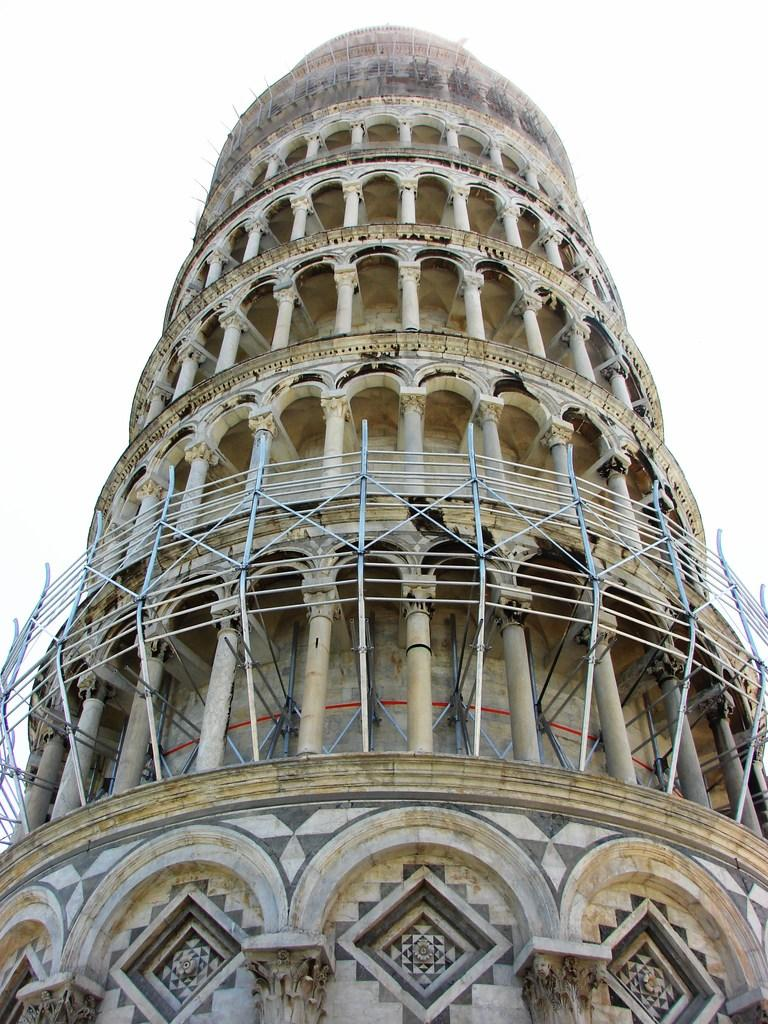What is the main structure in the image? There is a tower in the image. What architectural features can be seen on the tower? The tower has pillars. What can be seen in the background of the image? The sky is visible in the background of the image. What type of boot is hanging from the tower in the image? There is no boot present in the image; it only features a tower with pillars and a visible sky in the background. 